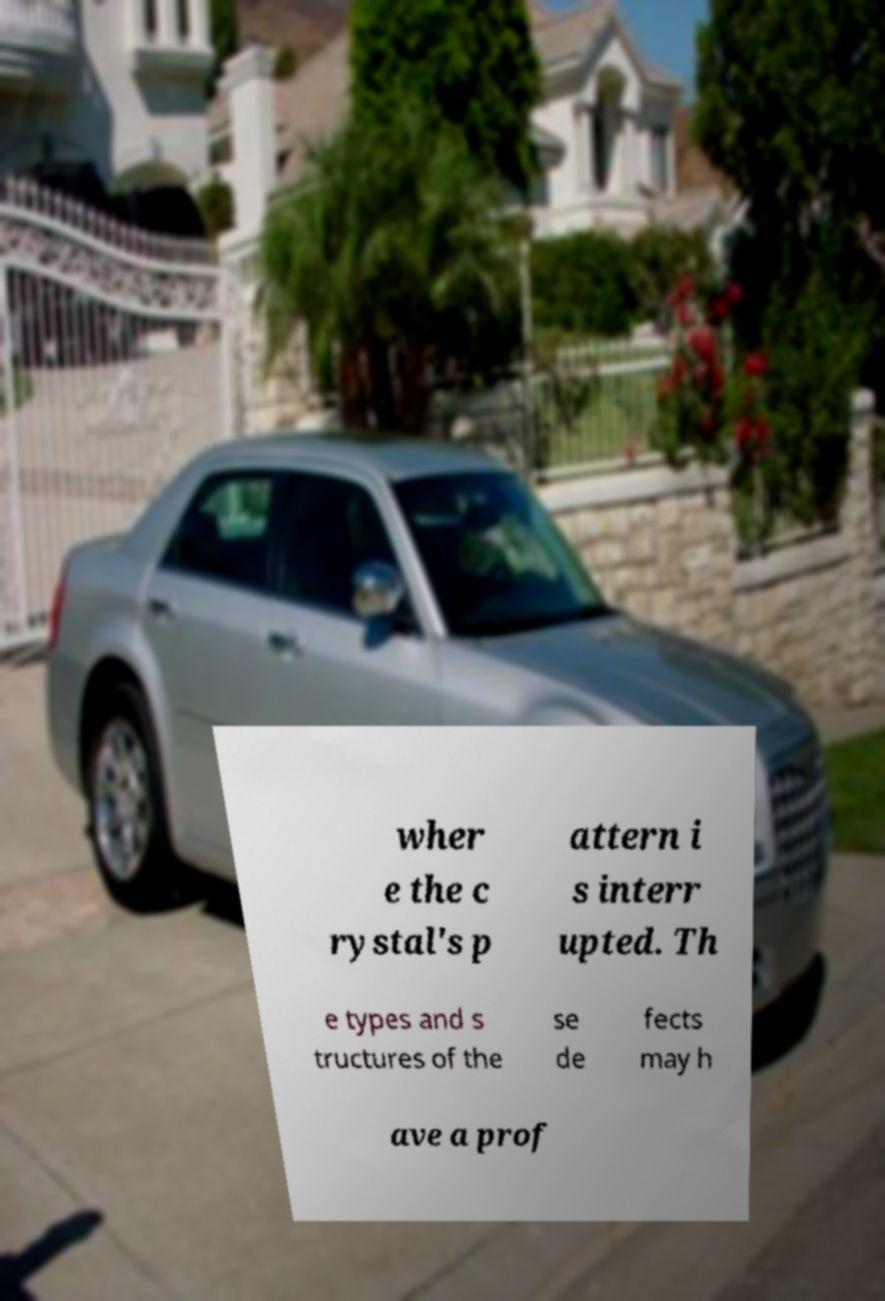Please read and relay the text visible in this image. What does it say? wher e the c rystal's p attern i s interr upted. Th e types and s tructures of the se de fects may h ave a prof 